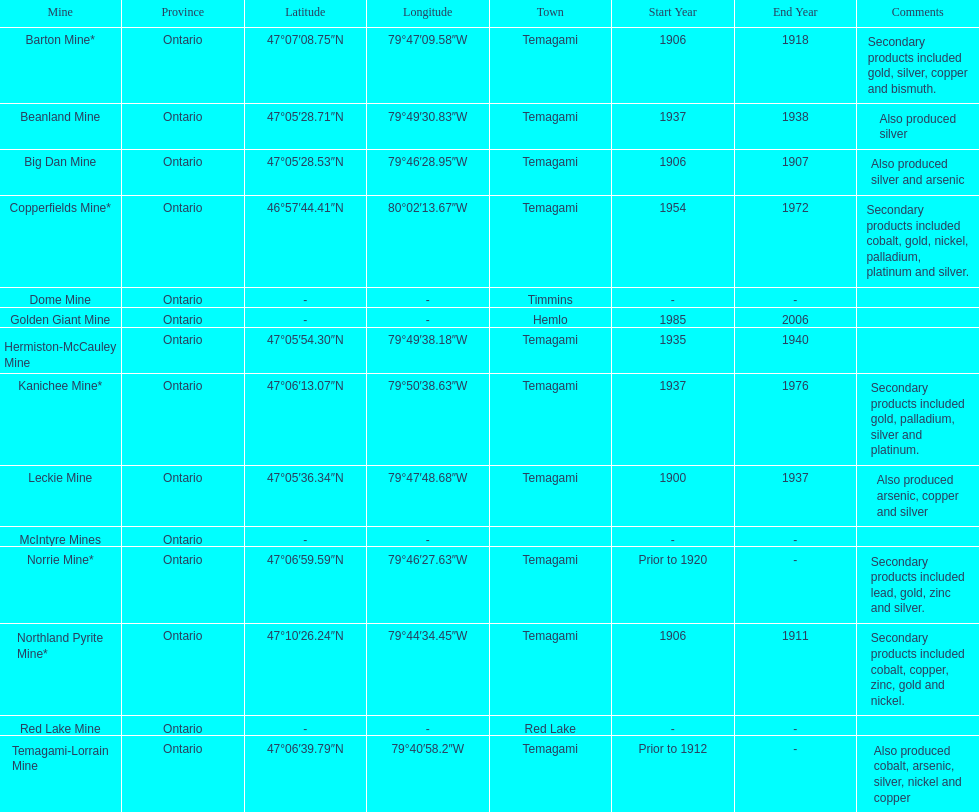Name a gold mine that was open at least 10 years. Barton Mine. 